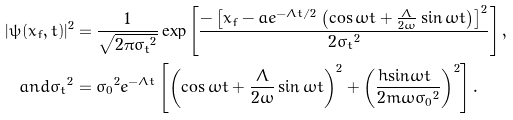Convert formula to latex. <formula><loc_0><loc_0><loc_500><loc_500>| \psi ( x _ { f } , t ) | ^ { 2 } & = \frac { 1 } { \sqrt { 2 \pi { \sigma _ { t } } ^ { 2 } } } \exp \left [ \frac { - \left [ x _ { f } - a e ^ { - \Lambda t / 2 } \left ( \cos \omega t + \frac { \Lambda } { 2 \omega } \sin \omega t \right ) \right ] ^ { 2 } } { 2 { \sigma _ { t } } ^ { 2 } } \right ] , \\ { a n d } { \sigma _ { t } } ^ { 2 } & = { \sigma _ { 0 } } ^ { 2 } e ^ { - \Lambda t } \left [ \left ( \cos \omega t + \frac { \Lambda } { 2 \omega } \sin \omega t \right ) ^ { 2 } + \left ( \frac { \hbar { \sin } \omega t } { 2 m \omega { \sigma _ { 0 } } ^ { 2 } } \right ) ^ { 2 } \right ] .</formula> 